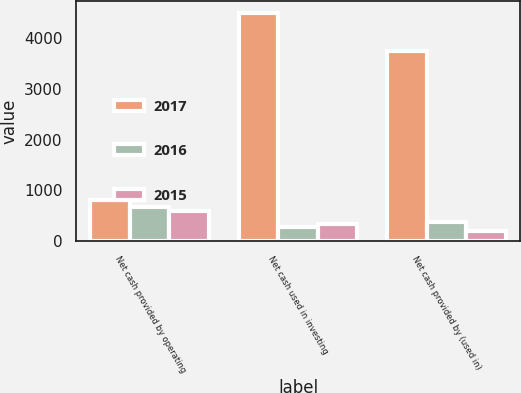Convert chart to OTSL. <chart><loc_0><loc_0><loc_500><loc_500><stacked_bar_chart><ecel><fcel>Net cash provided by operating<fcel>Net cash used in investing<fcel>Net cash provided by (used in)<nl><fcel>2017<fcel>815.3<fcel>4508.3<fcel>3756<nl><fcel>2016<fcel>658.1<fcel>267.1<fcel>371.5<nl><fcel>2015<fcel>590<fcel>338.9<fcel>199.6<nl></chart> 